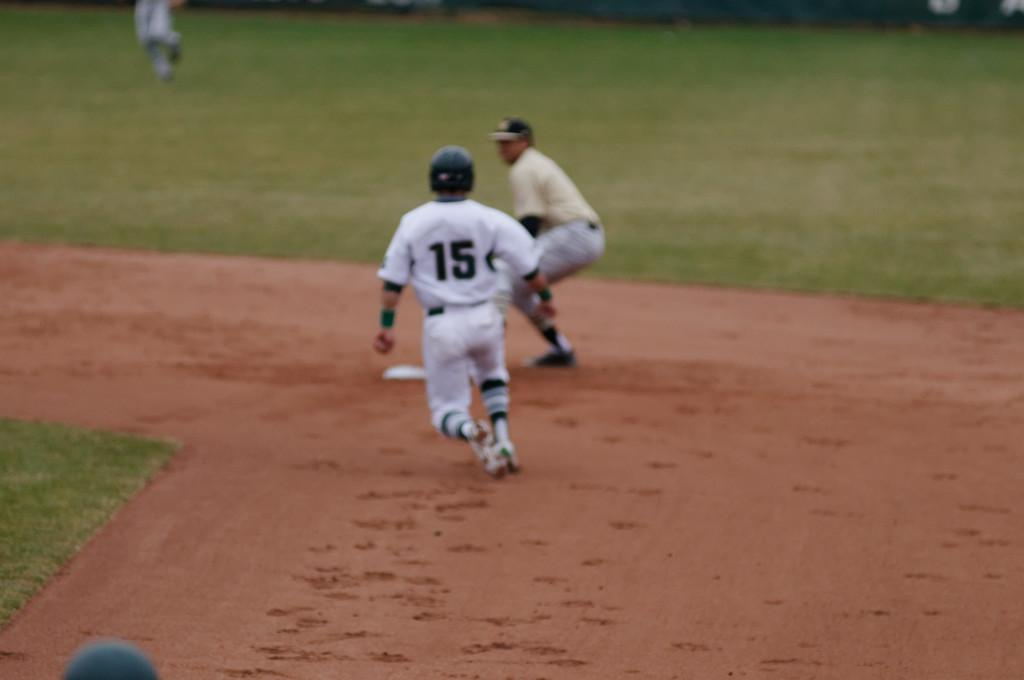<image>
Relay a brief, clear account of the picture shown. A baseball player with the number 15 on his back runs to a base 